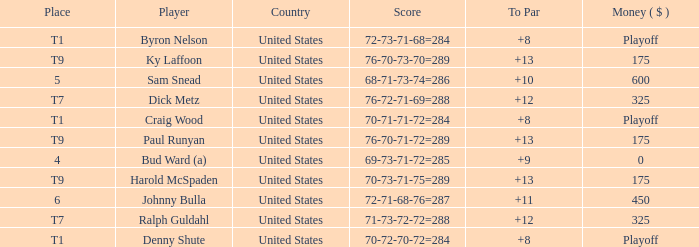What was the total To Par for Craig Wood? 8.0. 